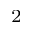<formula> <loc_0><loc_0><loc_500><loc_500>^ { 2 }</formula> 